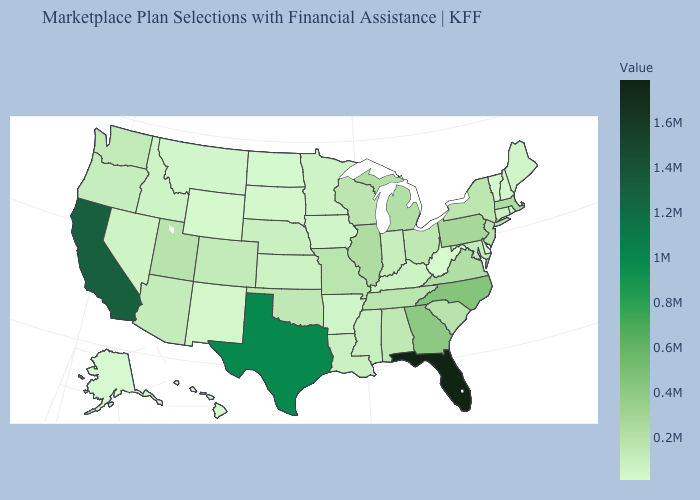Which states have the lowest value in the USA?
Concise answer only. Alaska. Does Hawaii have the highest value in the USA?
Give a very brief answer. No. Does Nebraska have a higher value than Georgia?
Answer briefly. No. Does Pennsylvania have the highest value in the USA?
Short answer required. No. 